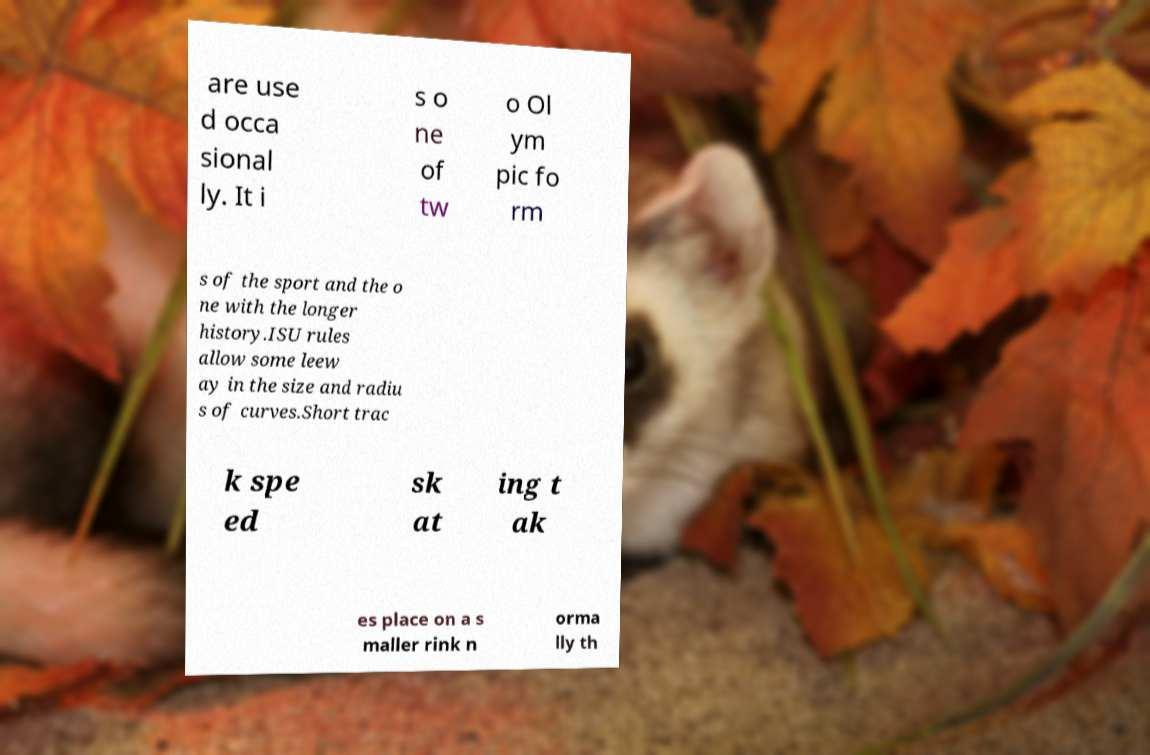Could you extract and type out the text from this image? are use d occa sional ly. It i s o ne of tw o Ol ym pic fo rm s of the sport and the o ne with the longer history.ISU rules allow some leew ay in the size and radiu s of curves.Short trac k spe ed sk at ing t ak es place on a s maller rink n orma lly th 